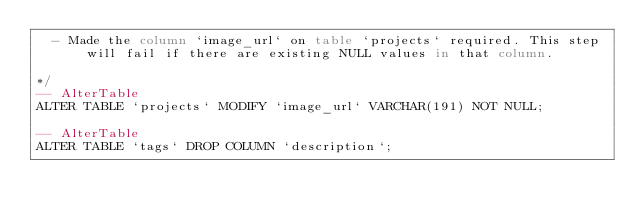<code> <loc_0><loc_0><loc_500><loc_500><_SQL_>  - Made the column `image_url` on table `projects` required. This step will fail if there are existing NULL values in that column.

*/
-- AlterTable
ALTER TABLE `projects` MODIFY `image_url` VARCHAR(191) NOT NULL;

-- AlterTable
ALTER TABLE `tags` DROP COLUMN `description`;
</code> 